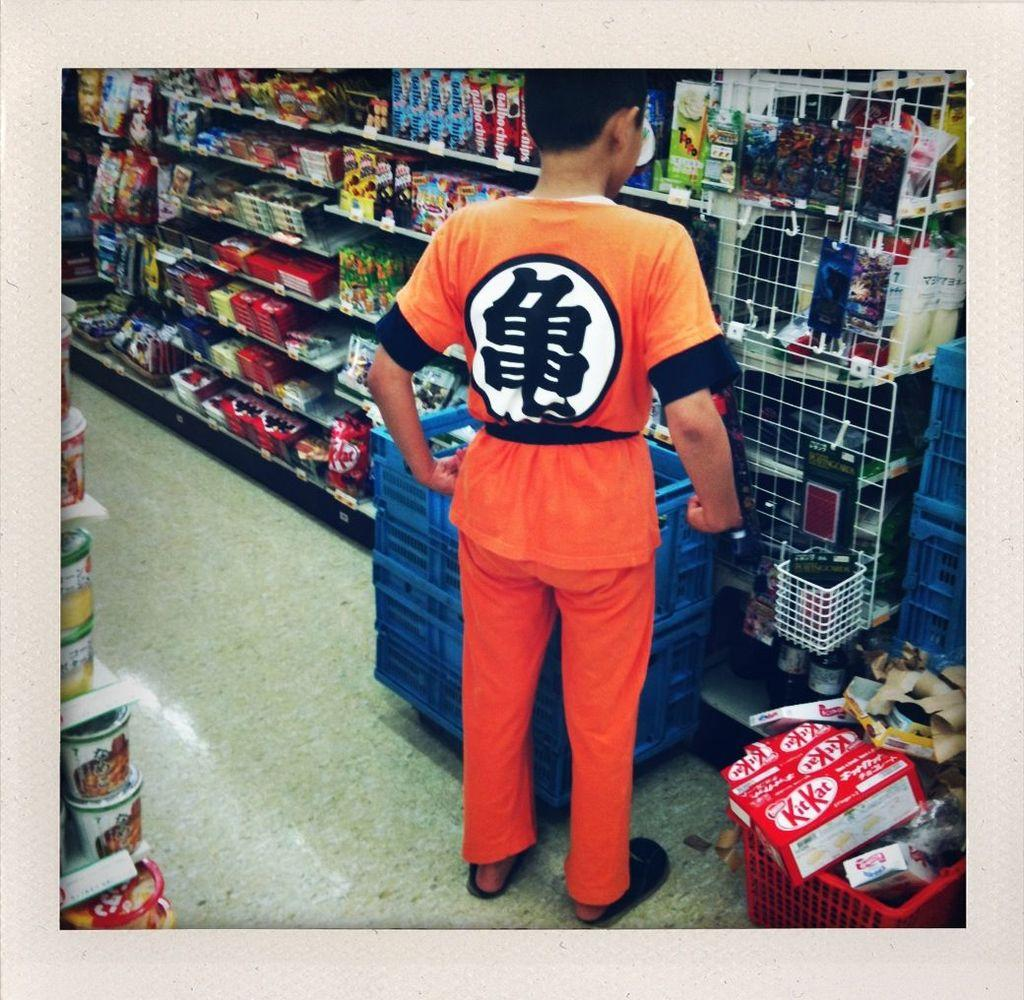<image>
Offer a succinct explanation of the picture presented. a grocery basket in a store with a box in it that was labeled 'kitkat' 